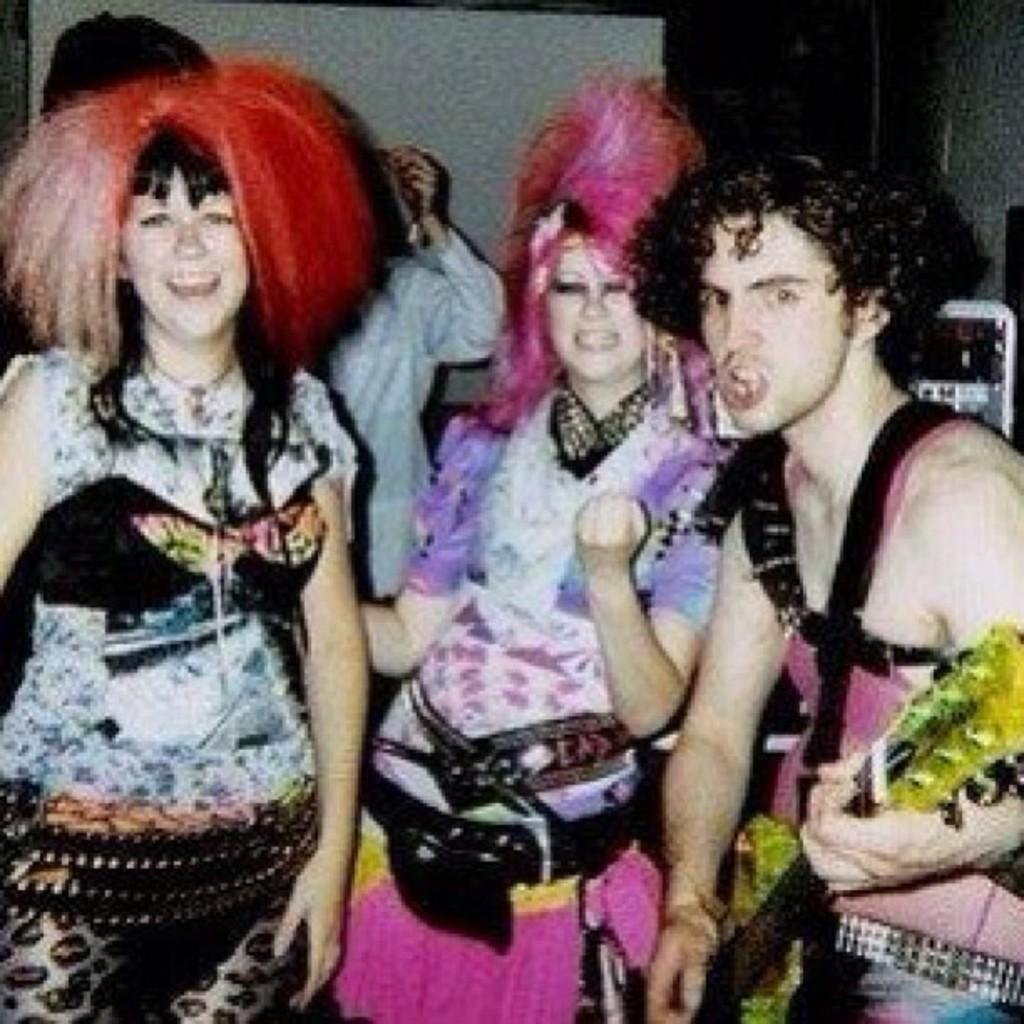How many people are in the image? There are three people in the image. Can you describe the gender of the people? Two of the people are girls, and one is a boy. What are the girls wearing in the image? The two girls are wearing colorful dresses. What can be seen in the girls' hair? The two girls have wigs in their hair. What is visible in the background of the image? There is a wall in the background of the image. What type of title is written on the wall in the image? There is no title written on the wall in the image. How many spiders are crawling on the girls' dresses in the image? There are no spiders present in the image. 